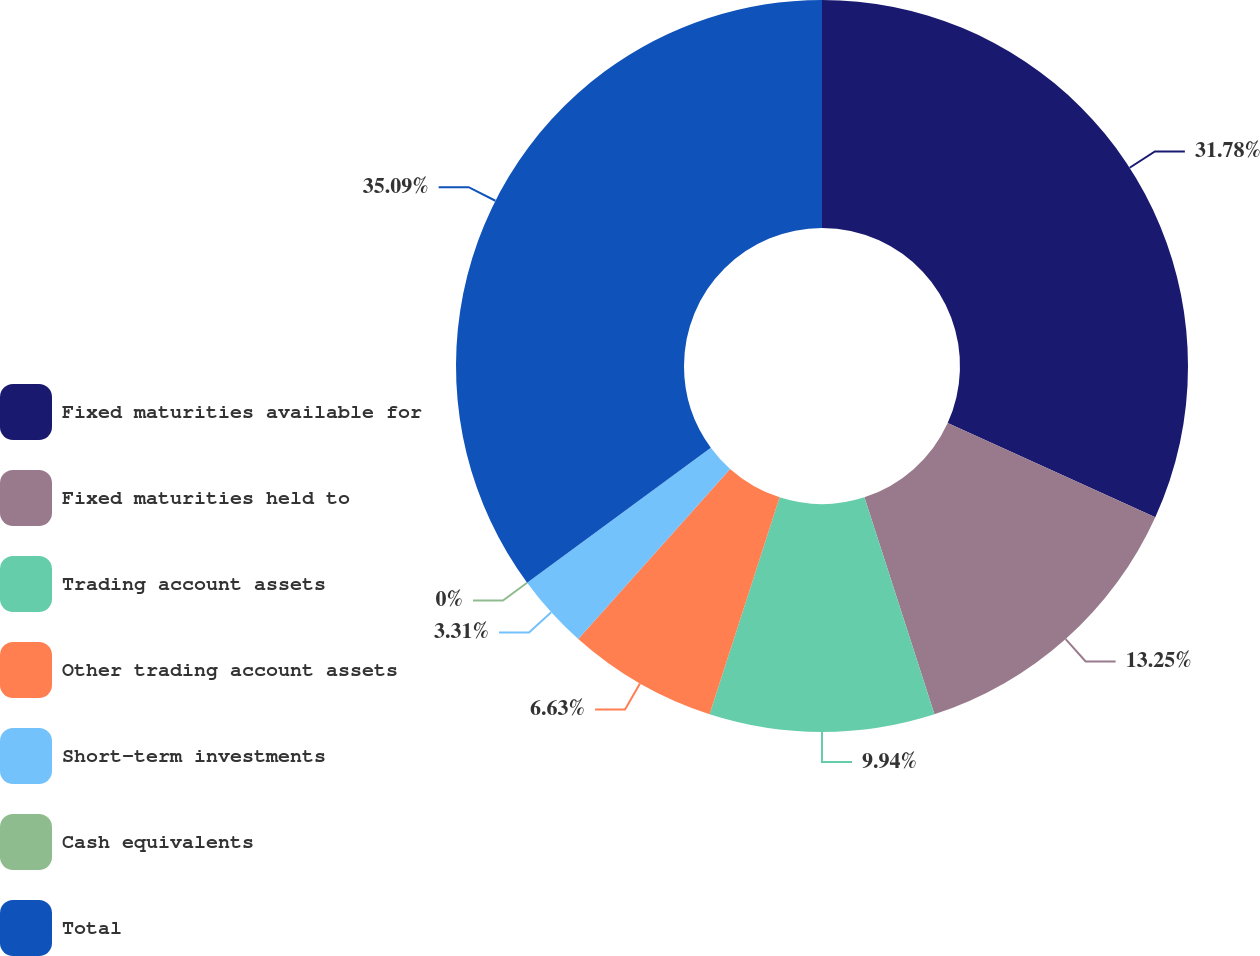<chart> <loc_0><loc_0><loc_500><loc_500><pie_chart><fcel>Fixed maturities available for<fcel>Fixed maturities held to<fcel>Trading account assets<fcel>Other trading account assets<fcel>Short-term investments<fcel>Cash equivalents<fcel>Total<nl><fcel>31.78%<fcel>13.25%<fcel>9.94%<fcel>6.63%<fcel>3.31%<fcel>0.0%<fcel>35.09%<nl></chart> 